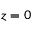Convert formula to latex. <formula><loc_0><loc_0><loc_500><loc_500>z = 0</formula> 